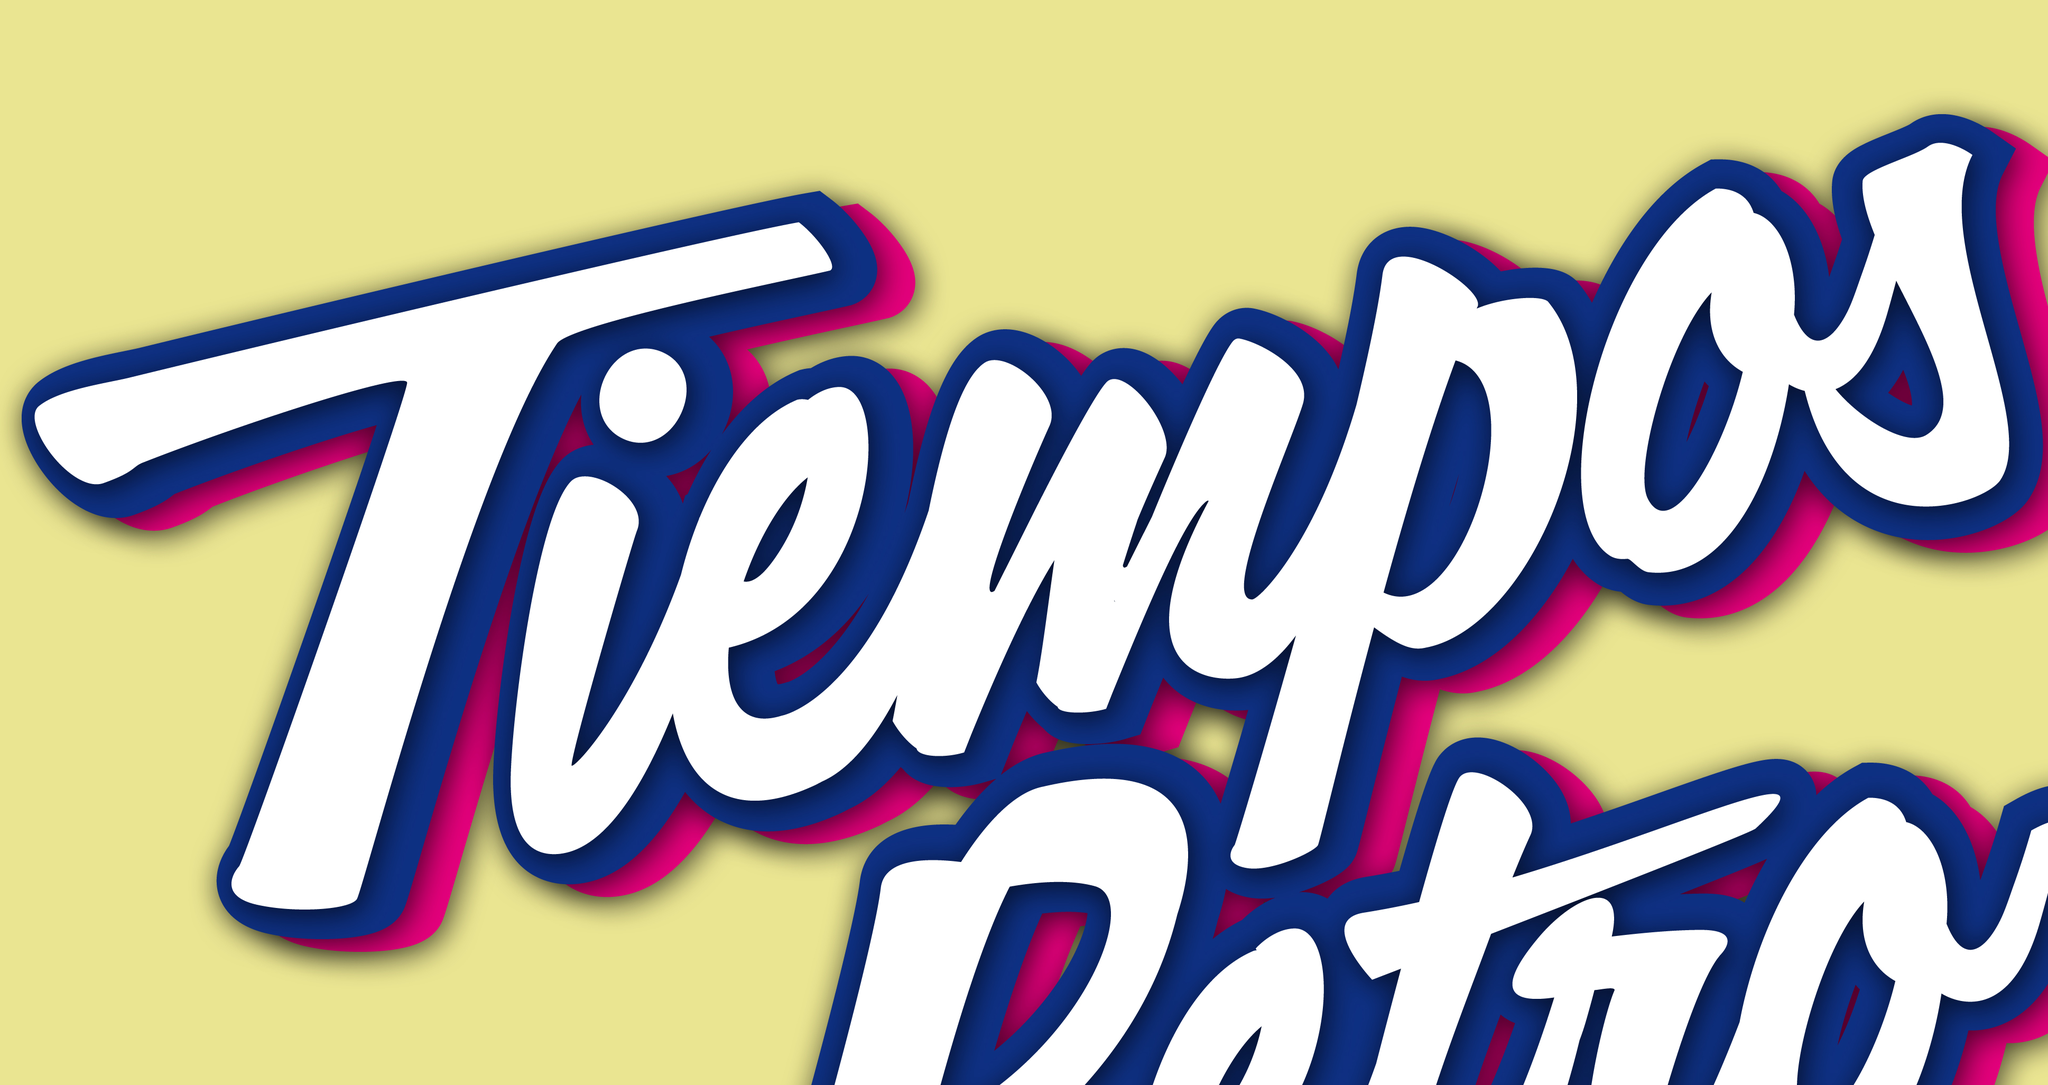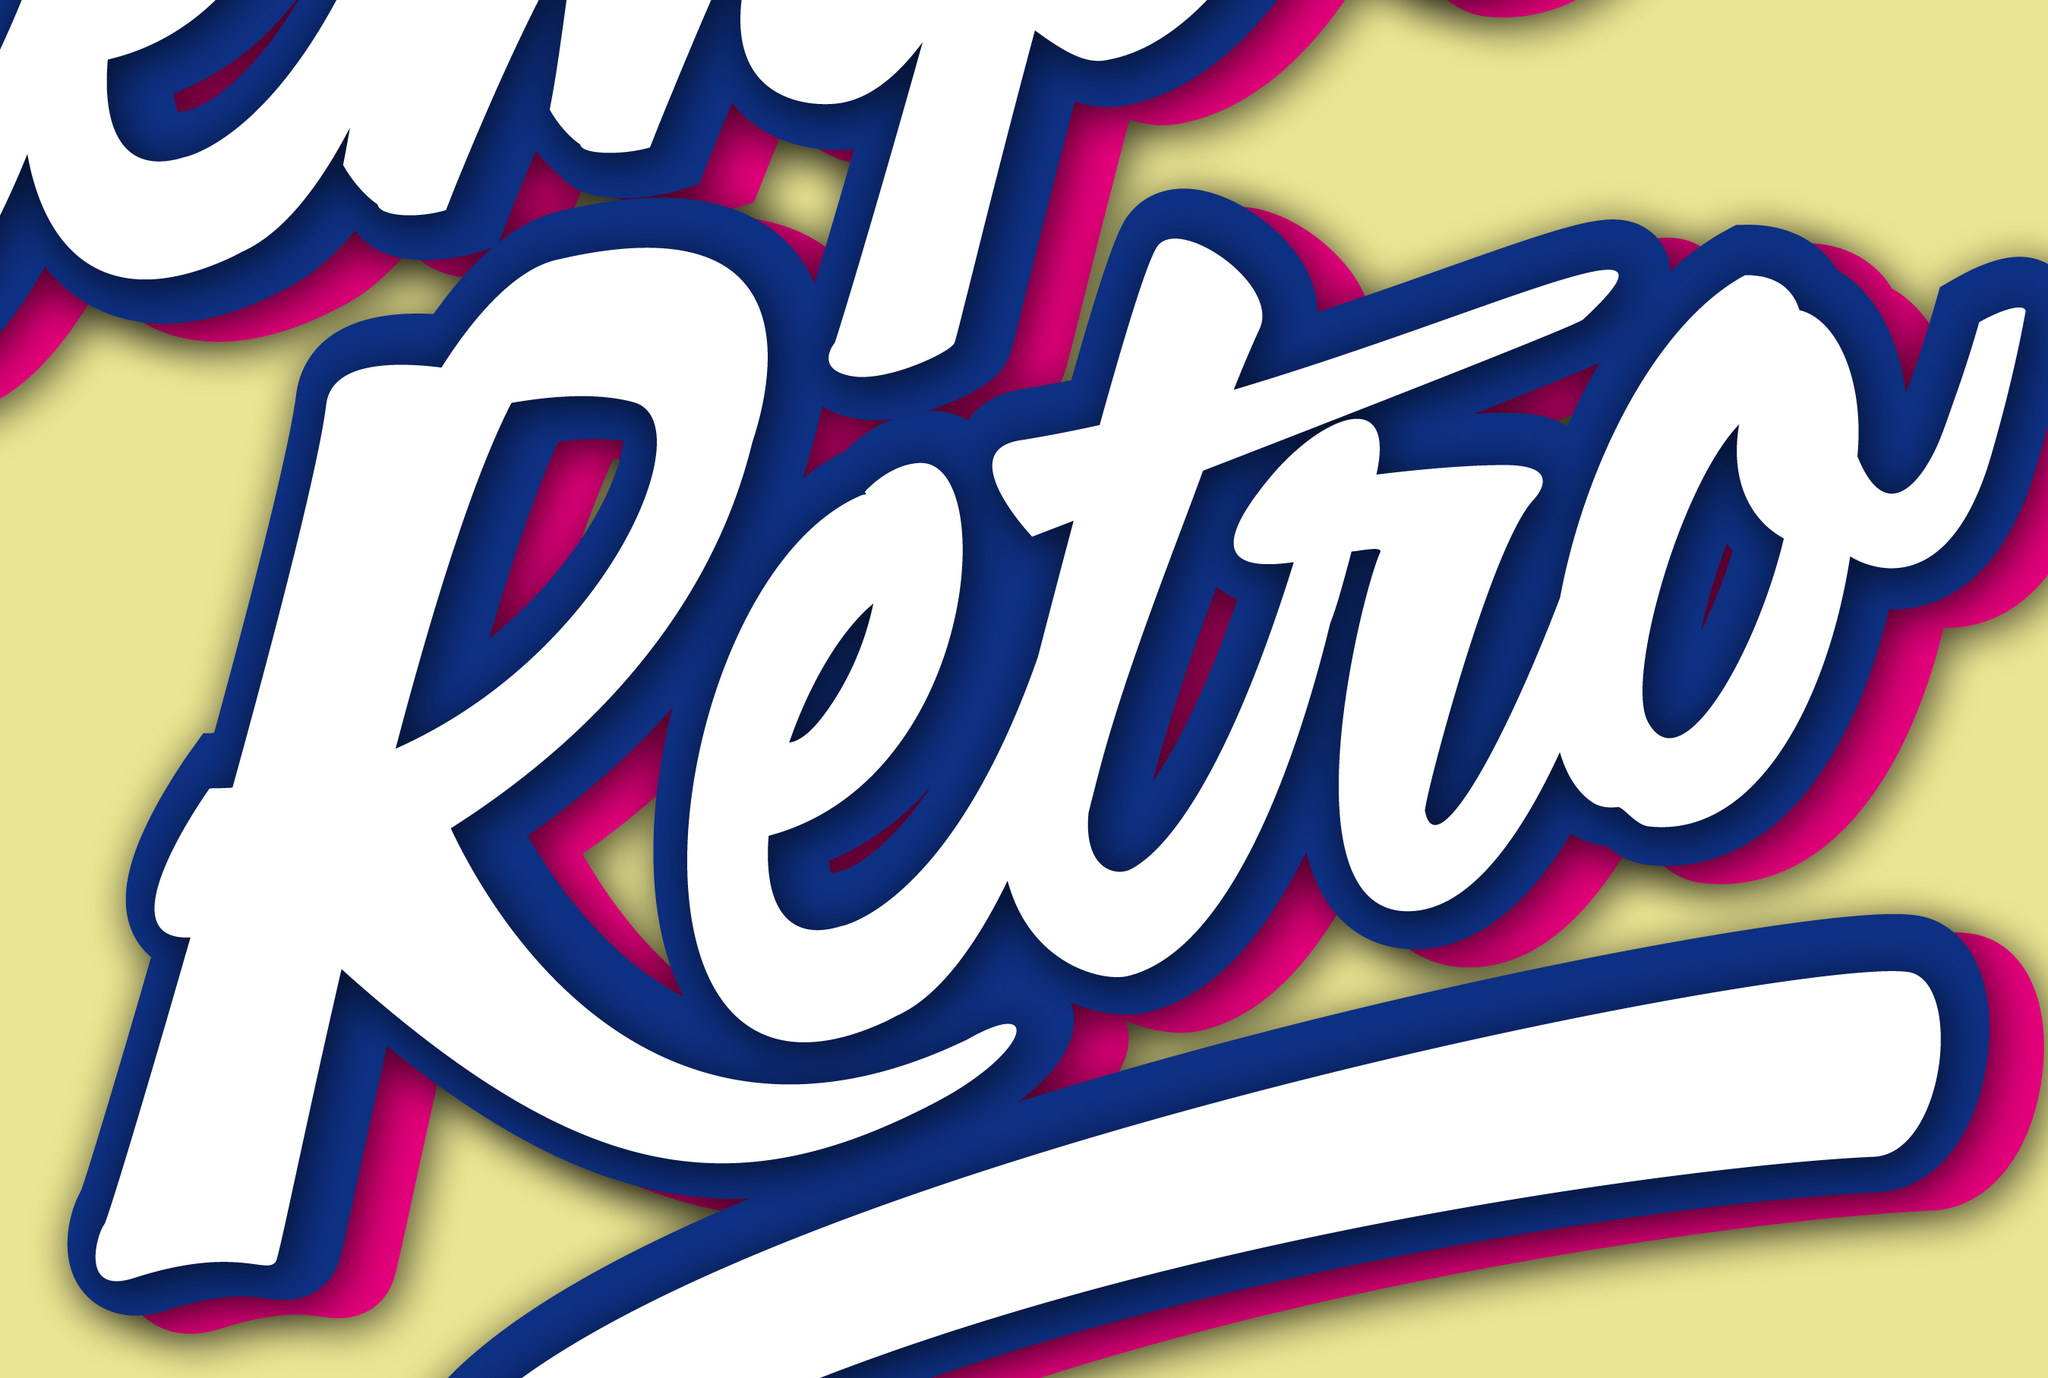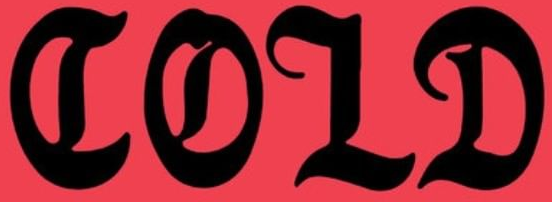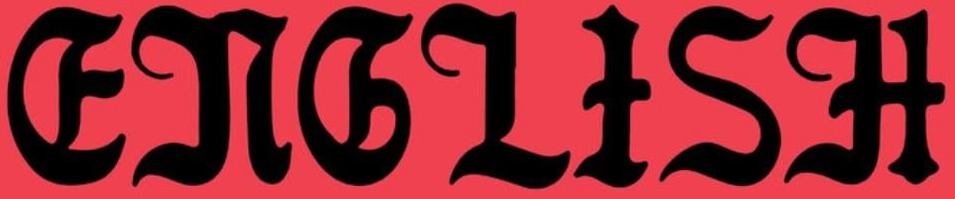Read the text content from these images in order, separated by a semicolon. Tiempos; Retro; COLD; ENGLISH 